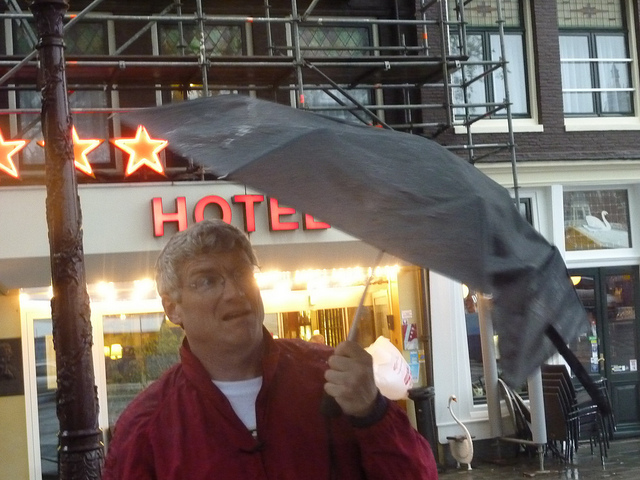Can you comment on the urban environment seen in the background? Certainly! In the background, there's a building with a sign that reads 'HOTEL,' which, along with the star decorations and the outdoor seating, suggests this scene is in a city area with accommodations for travelers and possibly some cafes or restaurants nearby. Are there any indications of the location or country where this photo might have been taken? While the specific location isn't identifiable, the architecture of the buildings, the signage, and the overall atmosphere could suggest a European city. This is largely interpretive, as there aren't definitive markers that reveal the exact location. 